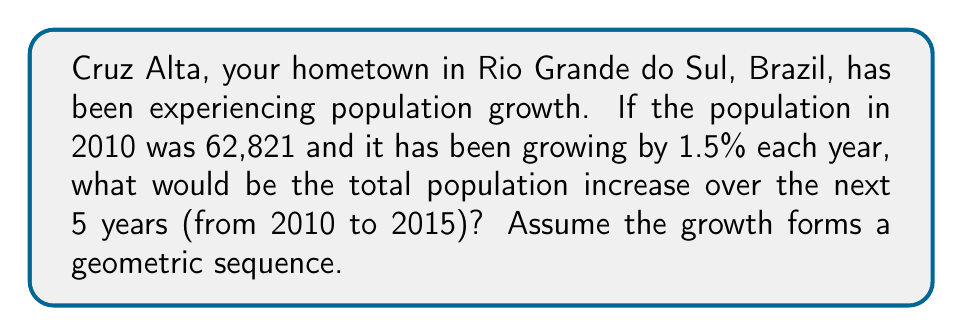Teach me how to tackle this problem. Let's approach this step-by-step:

1) The initial population (in 2010) is $a = 62,821$.

2) The common ratio of the geometric sequence is $r = 1.015$ (1 + 0.015, as the growth rate is 1.5% per year).

3) We need to find the sum of the population increases over 5 years. This can be represented as:

   $S = (ar - a) + (ar^2 - ar) + (ar^3 - ar^2) + (ar^4 - ar^3) + (ar^5 - ar^4)$

4) This simplifies to:

   $S = ar^5 - a$

5) Now, let's calculate $ar^5$:
   
   $ar^5 = 62,821 \times (1.015)^5 = 62,821 \times 1.0773 = 67,673$

6) Therefore, the total increase is:

   $S = 67,673 - 62,821 = 4,852$

So, the total population increase over 5 years is 4,852 people.
Answer: 4,852 people 